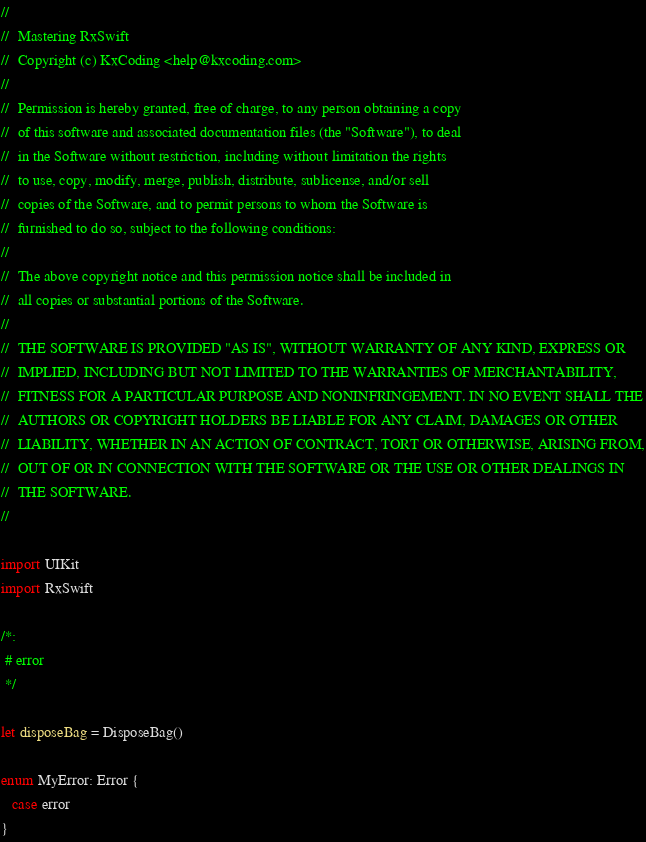Convert code to text. <code><loc_0><loc_0><loc_500><loc_500><_Swift_>//
//  Mastering RxSwift
//  Copyright (c) KxCoding <help@kxcoding.com>
//
//  Permission is hereby granted, free of charge, to any person obtaining a copy
//  of this software and associated documentation files (the "Software"), to deal
//  in the Software without restriction, including without limitation the rights
//  to use, copy, modify, merge, publish, distribute, sublicense, and/or sell
//  copies of the Software, and to permit persons to whom the Software is
//  furnished to do so, subject to the following conditions:
//
//  The above copyright notice and this permission notice shall be included in
//  all copies or substantial portions of the Software.
//
//  THE SOFTWARE IS PROVIDED "AS IS", WITHOUT WARRANTY OF ANY KIND, EXPRESS OR
//  IMPLIED, INCLUDING BUT NOT LIMITED TO THE WARRANTIES OF MERCHANTABILITY,
//  FITNESS FOR A PARTICULAR PURPOSE AND NONINFRINGEMENT. IN NO EVENT SHALL THE
//  AUTHORS OR COPYRIGHT HOLDERS BE LIABLE FOR ANY CLAIM, DAMAGES OR OTHER
//  LIABILITY, WHETHER IN AN ACTION OF CONTRACT, TORT OR OTHERWISE, ARISING FROM,
//  OUT OF OR IN CONNECTION WITH THE SOFTWARE OR THE USE OR OTHER DEALINGS IN
//  THE SOFTWARE.
//

import UIKit
import RxSwift

/*:
 # error
 */

let disposeBag = DisposeBag()

enum MyError: Error {
   case error
}












</code> 